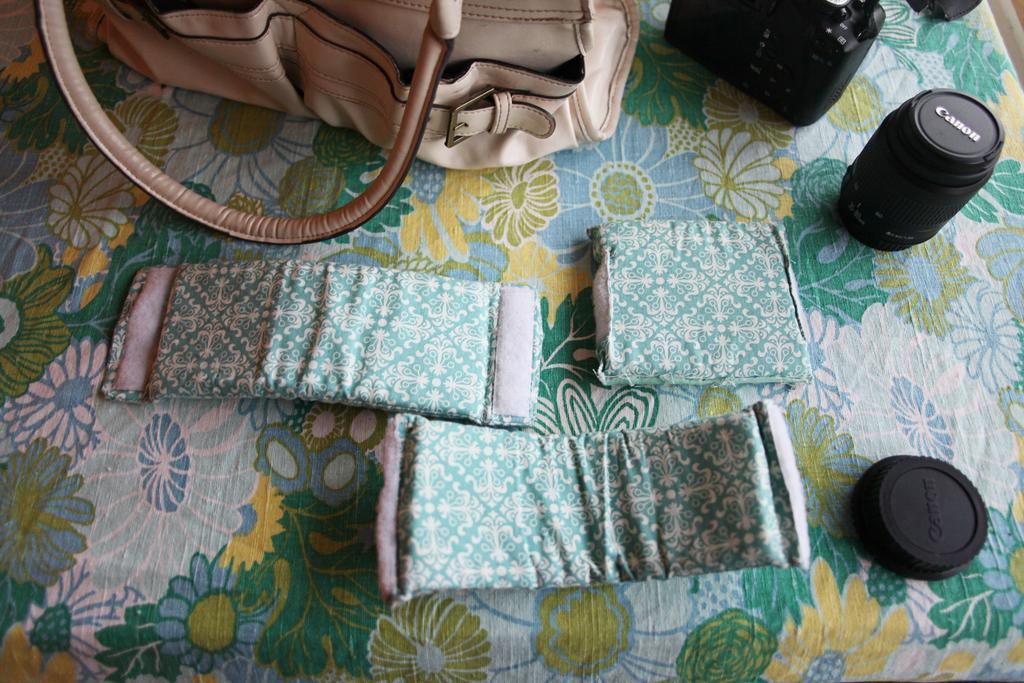How would you summarize this image in a sentence or two? In this picture we can see a bag, camera, camera lenses and a camera cap. 